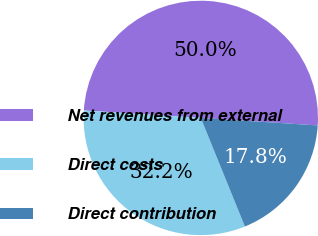Convert chart to OTSL. <chart><loc_0><loc_0><loc_500><loc_500><pie_chart><fcel>Net revenues from external<fcel>Direct costs<fcel>Direct contribution<nl><fcel>50.0%<fcel>32.16%<fcel>17.84%<nl></chart> 